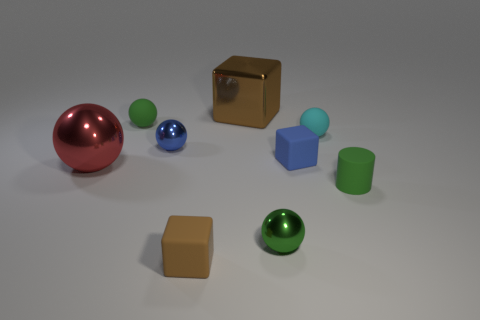Do the matte block in front of the small green matte cylinder and the matte cube on the right side of the big brown block have the same color?
Provide a succinct answer. No. Is the number of small balls that are to the right of the big brown thing less than the number of brown cubes?
Your answer should be very brief. No. How many things are large brown objects or tiny things in front of the red shiny sphere?
Offer a terse response. 4. What is the color of the small cylinder that is made of the same material as the small brown block?
Make the answer very short. Green. What number of objects are tiny blue matte blocks or green matte cylinders?
Offer a very short reply. 2. There is a cylinder that is the same size as the cyan object; what is its color?
Your answer should be compact. Green. How many things are big things that are on the right side of the brown rubber block or large blue metal objects?
Provide a short and direct response. 1. How many other objects are there of the same size as the blue shiny ball?
Keep it short and to the point. 6. There is a brown cube behind the green metallic thing; how big is it?
Keep it short and to the point. Large. There is a big brown object that is the same material as the small blue sphere; what is its shape?
Keep it short and to the point. Cube. 